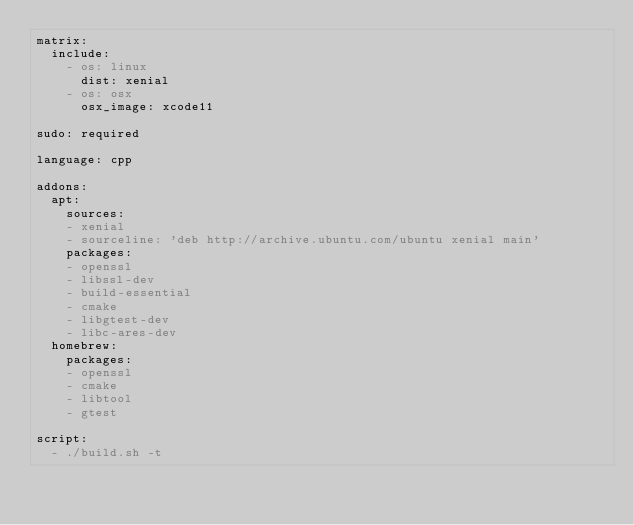Convert code to text. <code><loc_0><loc_0><loc_500><loc_500><_YAML_>matrix:
  include:
    - os: linux
      dist: xenial
    - os: osx
      osx_image: xcode11

sudo: required

language: cpp

addons:
  apt:
    sources:
    - xenial
    - sourceline: 'deb http://archive.ubuntu.com/ubuntu xenial main'
    packages:
    - openssl
    - libssl-dev
    - build-essential
    - cmake
    - libgtest-dev
    - libc-ares-dev
  homebrew:
    packages:
    - openssl
    - cmake
    - libtool
    - gtest

script:
  - ./build.sh -t
</code> 